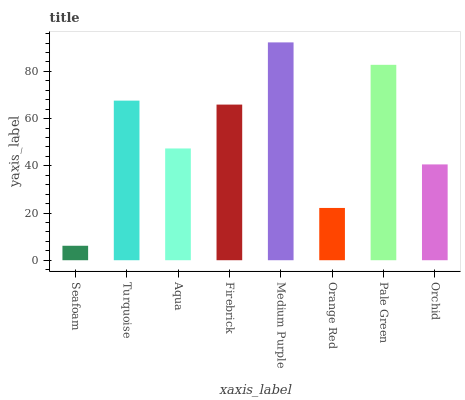Is Seafoam the minimum?
Answer yes or no. Yes. Is Medium Purple the maximum?
Answer yes or no. Yes. Is Turquoise the minimum?
Answer yes or no. No. Is Turquoise the maximum?
Answer yes or no. No. Is Turquoise greater than Seafoam?
Answer yes or no. Yes. Is Seafoam less than Turquoise?
Answer yes or no. Yes. Is Seafoam greater than Turquoise?
Answer yes or no. No. Is Turquoise less than Seafoam?
Answer yes or no. No. Is Firebrick the high median?
Answer yes or no. Yes. Is Aqua the low median?
Answer yes or no. Yes. Is Turquoise the high median?
Answer yes or no. No. Is Turquoise the low median?
Answer yes or no. No. 